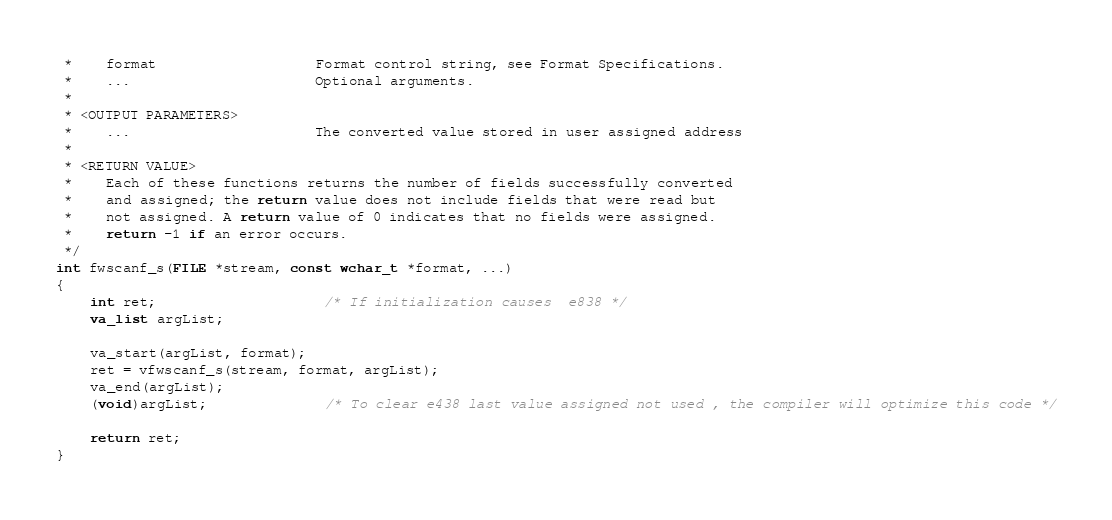Convert code to text. <code><loc_0><loc_0><loc_500><loc_500><_C_> *    format                   Format control string, see Format Specifications.
 *    ...                      Optional arguments.
 *
 * <OUTPUT PARAMETERS>
 *    ...                      The converted value stored in user assigned address
 *
 * <RETURN VALUE>
 *    Each of these functions returns the number of fields successfully converted
 *    and assigned; the return value does not include fields that were read but
 *    not assigned. A return value of 0 indicates that no fields were assigned.
 *    return -1 if an error occurs.
 */
int fwscanf_s(FILE *stream, const wchar_t *format, ...)
{
    int ret;                    /* If initialization causes  e838 */
    va_list argList;

    va_start(argList, format);
    ret = vfwscanf_s(stream, format, argList);
    va_end(argList);
    (void)argList;              /* To clear e438 last value assigned not used , the compiler will optimize this code */

    return ret;
}


</code> 